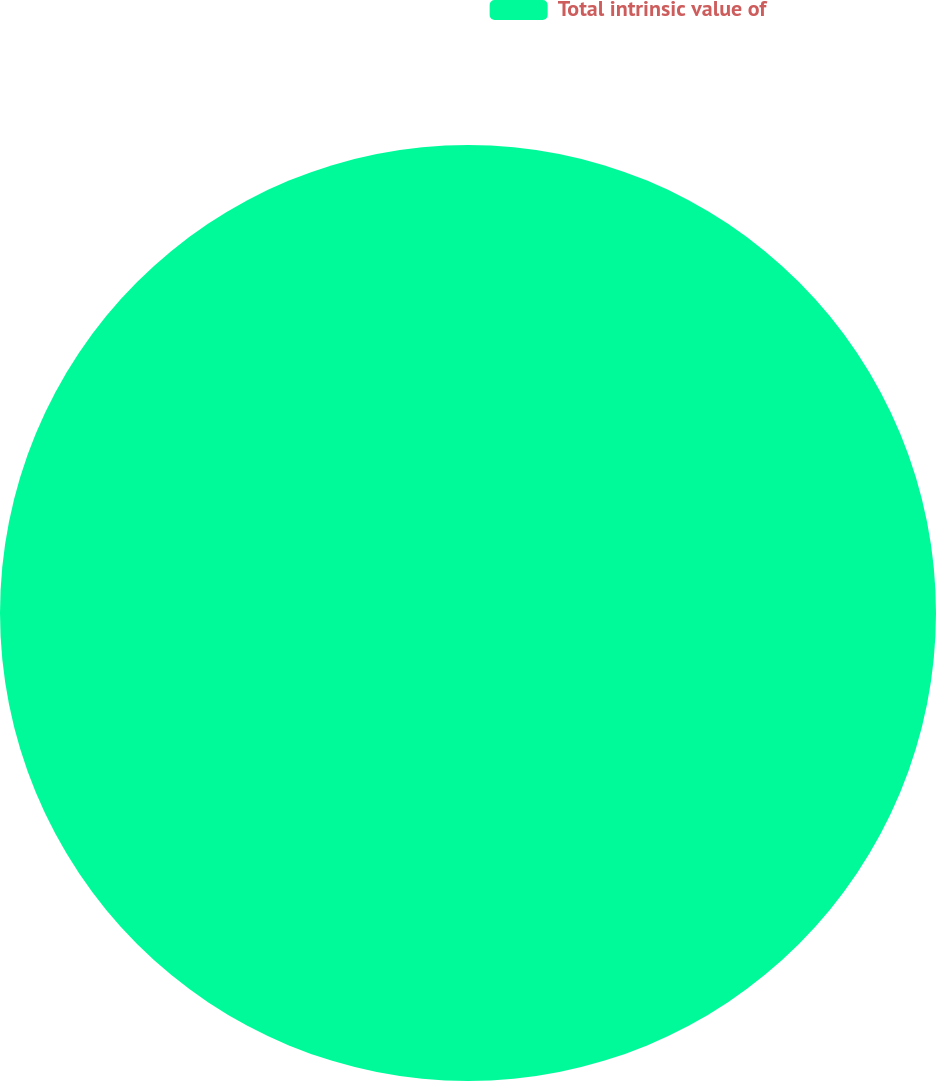Convert chart to OTSL. <chart><loc_0><loc_0><loc_500><loc_500><pie_chart><fcel>Total intrinsic value of<nl><fcel>100.0%<nl></chart> 